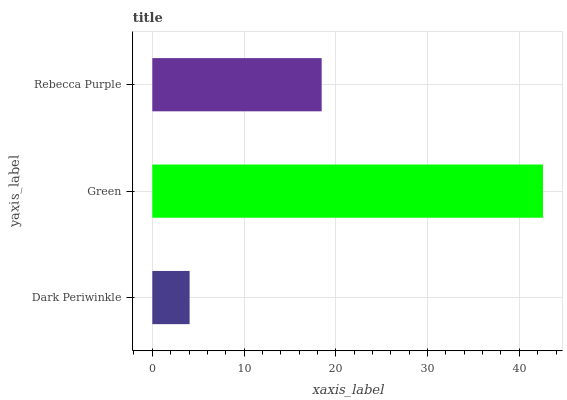Is Dark Periwinkle the minimum?
Answer yes or no. Yes. Is Green the maximum?
Answer yes or no. Yes. Is Rebecca Purple the minimum?
Answer yes or no. No. Is Rebecca Purple the maximum?
Answer yes or no. No. Is Green greater than Rebecca Purple?
Answer yes or no. Yes. Is Rebecca Purple less than Green?
Answer yes or no. Yes. Is Rebecca Purple greater than Green?
Answer yes or no. No. Is Green less than Rebecca Purple?
Answer yes or no. No. Is Rebecca Purple the high median?
Answer yes or no. Yes. Is Rebecca Purple the low median?
Answer yes or no. Yes. Is Dark Periwinkle the high median?
Answer yes or no. No. Is Green the low median?
Answer yes or no. No. 